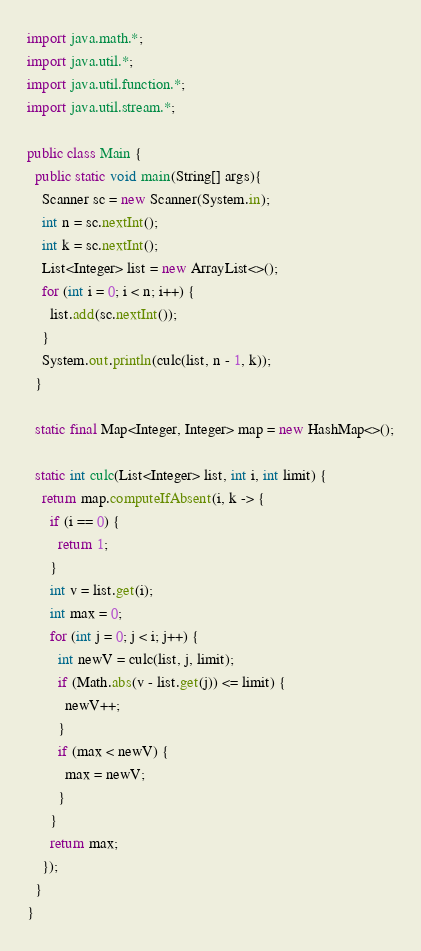Convert code to text. <code><loc_0><loc_0><loc_500><loc_500><_Java_>import java.math.*;
import java.util.*;
import java.util.function.*;
import java.util.stream.*;

public class Main {
  public static void main(String[] args){
    Scanner sc = new Scanner(System.in);
    int n = sc.nextInt();
    int k = sc.nextInt();
    List<Integer> list = new ArrayList<>();
    for (int i = 0; i < n; i++) {
      list.add(sc.nextInt());
    }
    System.out.println(culc(list, n - 1, k));
  }

  static final Map<Integer, Integer> map = new HashMap<>();

  static int culc(List<Integer> list, int i, int limit) {
    return map.computeIfAbsent(i, k -> {
      if (i == 0) {
        return 1;
      }
      int v = list.get(i);
      int max = 0;
      for (int j = 0; j < i; j++) {
        int newV = culc(list, j, limit);
        if (Math.abs(v - list.get(j)) <= limit) {
          newV++;
        }
        if (max < newV) {
          max = newV;
        }
      }
      return max;
    });
  }
}
</code> 